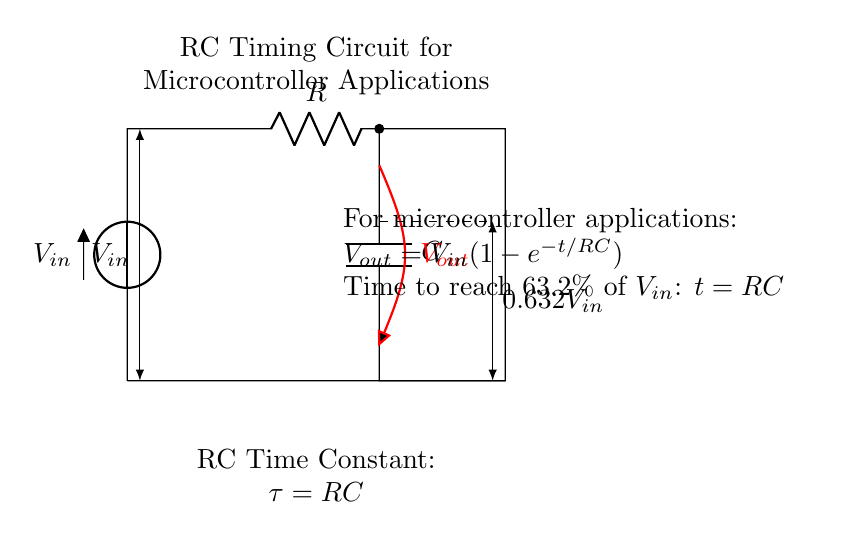What are the main components in the circuit? The main components are a resistor and a capacitor, which are connected in series in the circuit.
Answer: Resistor and Capacitor What is the time constant of the RC circuit? The time constant is calculated as the product of resistance (R) and capacitance (C), represented by the formula tau = RC.
Answer: RC What is the output voltage at time equal to the time constant? The output voltage, according to the RC charging equation, reaches approximately 63.2 percent of the input voltage at time equal to the time constant.
Answer: 0.632V_in What role does the resistor play in this circuit? The resistor limits the current flowing into the capacitor, which affects how quickly the capacitor charges and discharges over time.
Answer: Current Limiting If the resistance (R) doubles, how does that affect the time constant? If the resistance doubles, the time constant also doubles because the time constant is directly proportional to resistance, according to tau = RC.
Answer: Doubles At what time does the voltage achieve approximately 63.2 percent of V_in? This occurs at a time equal to the time constant, which is when t = RC, based on the charging behavior of the RC circuit.
Answer: t = RC 